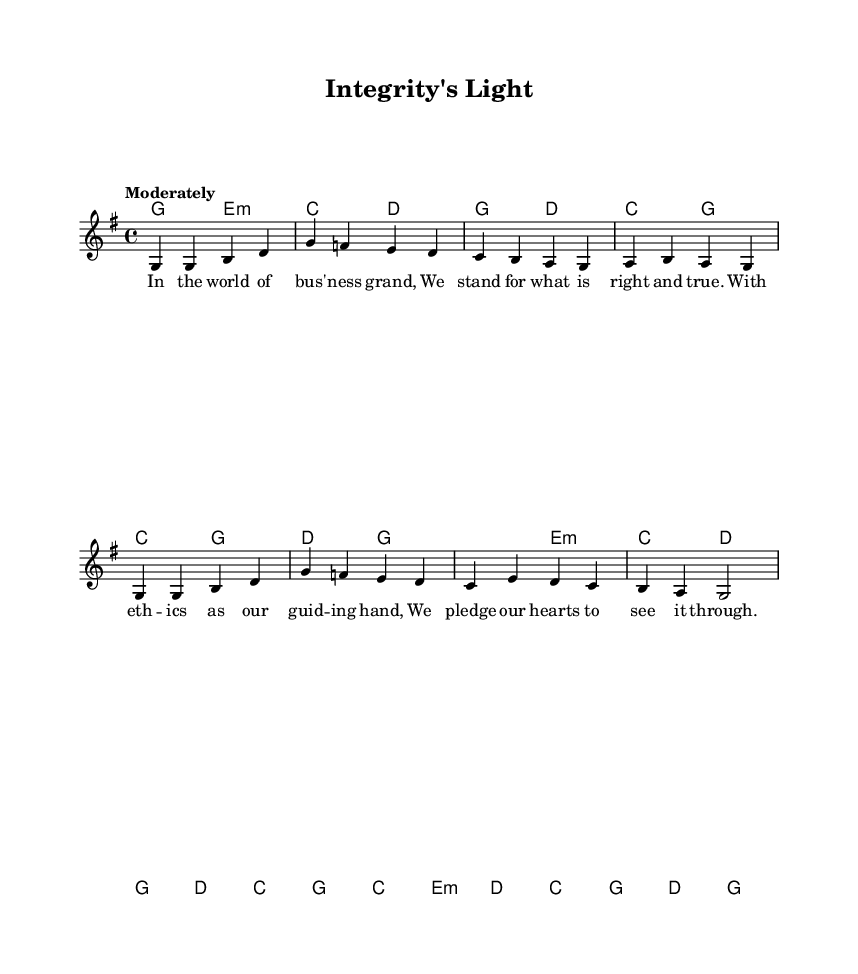What is the key signature of this music? The key signature is G major, which has one sharp (F#). This can be determined by observing the key signature indicated at the beginning of the sheet music.
Answer: G major What is the time signature of this piece? The time signature of the piece is 4/4, which is indicated at the beginning of the sheet music. This means there are four beats in each measure, and the quarter note receives one beat.
Answer: 4/4 What is the tempo marking of this hymn? The tempo marking is "Moderately," which suggests a moderate speed for performing the piece. This term is often placed above the staff near the beginning of the sheet music.
Answer: Moderately How many lines are in the lyrics? There are four lines of lyrics, each corresponding to musical phrases within the melody. You can count the separate lines of text provided in the lyric mode section of the sheet music.
Answer: Four What is the first word of the hymn’s lyrics? The first word of the hymn’s lyrics is "In." This can be determined by reading the first line of the lyrics provided in the sheet music.
Answer: In Which chord is played on the first beat of the first measure? The chord played on the first beat of the first measure is G major. This can be identified by looking at the chord indicated in the harmonies section at the beginning of the first measure.
Answer: G major What theme does the hymn primarily celebrate? The hymn celebrates corporate ethics and integrity. This can be inferred from the overall message of the lyrics which emphasizes rightness and truth in a business context.
Answer: Corporate ethics and integrity 